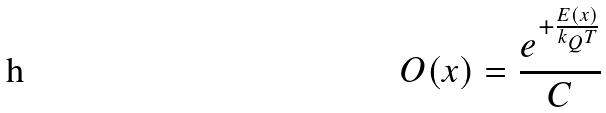<formula> <loc_0><loc_0><loc_500><loc_500>O ( x ) = \frac { e ^ { + \frac { E ( x ) } { k _ { Q } T } } } { C }</formula> 